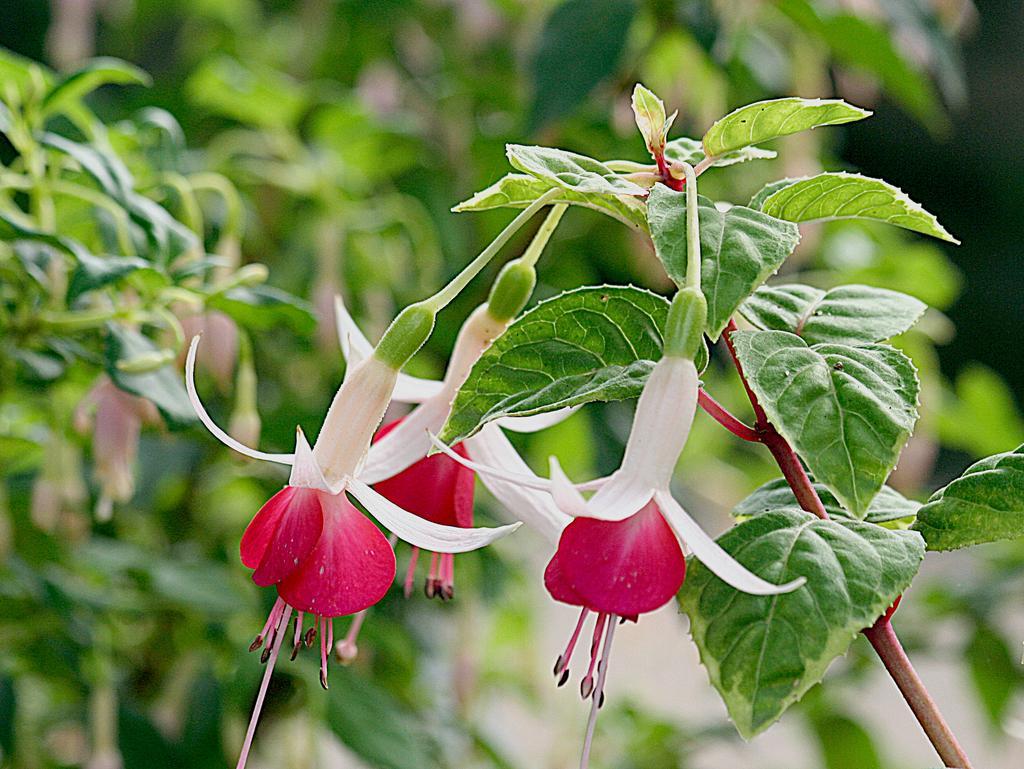In one or two sentences, can you explain what this image depicts? This picture shows few trees and few flowers to a plant. 